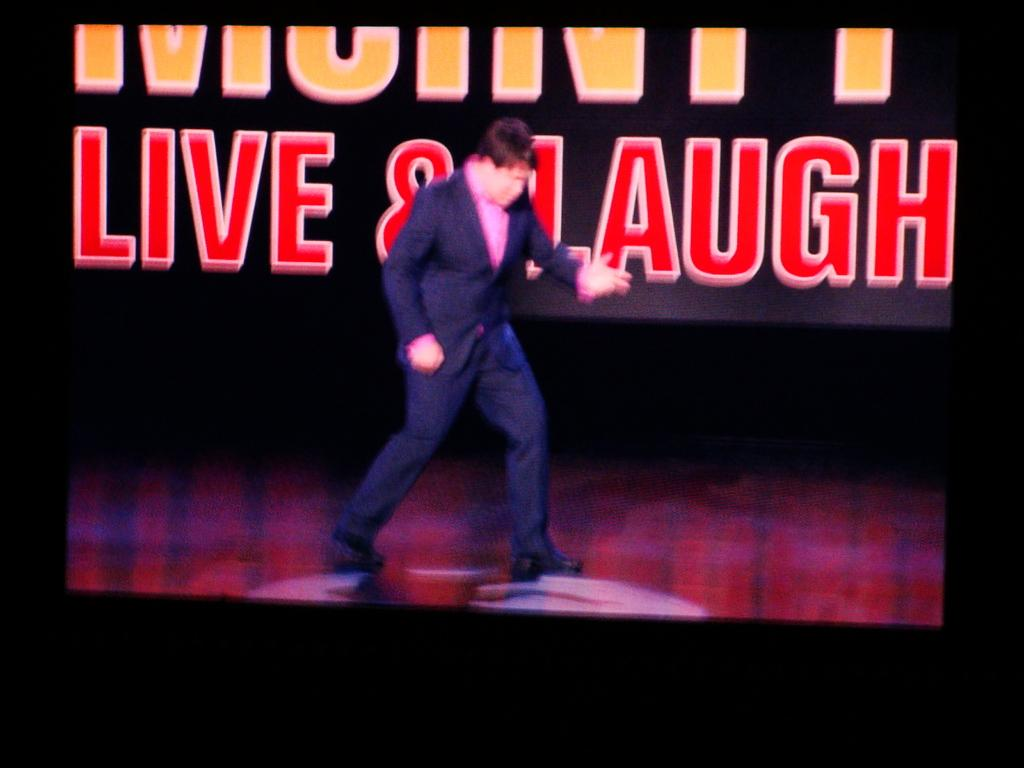What is happening in the image? There is a person on the stage in the image. Can you describe the background of the image? There is text visible in the background of the image. What type of plant is growing in the background of the image? There is no plant visible in the background of the image. What process is being performed by the person on the stage? The image does not provide enough information to determine the specific process being performed by the person on the stage. 